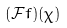<formula> <loc_0><loc_0><loc_500><loc_500>( { \mathcal { F } } f ) ( \chi )</formula> 